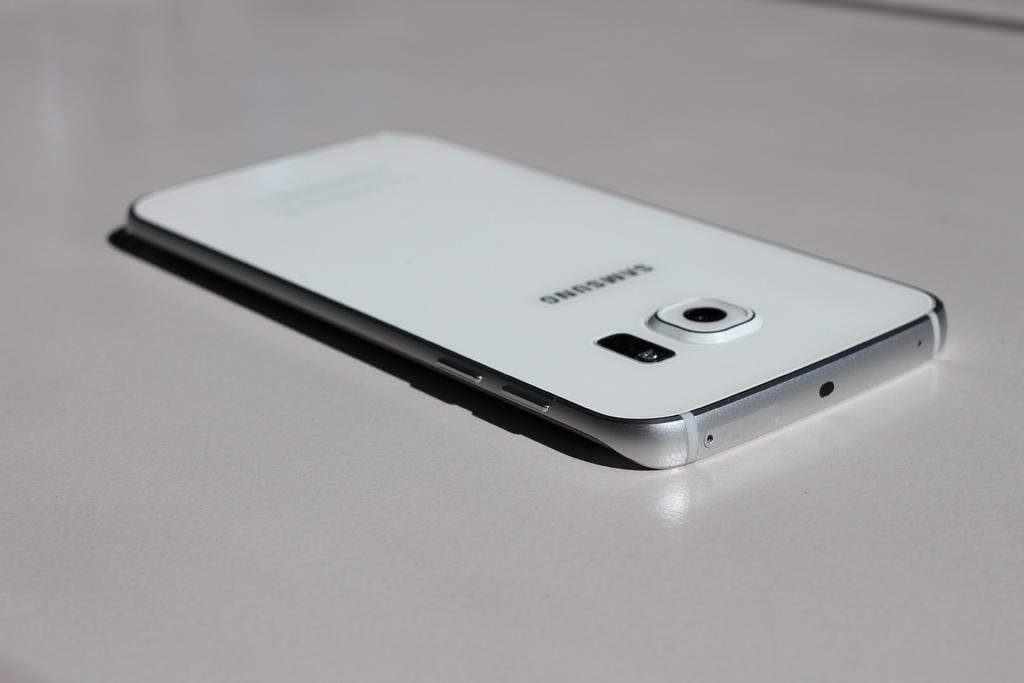Provide a one-sentence caption for the provided image. Samsung white cellphone that is laying down on a table. 